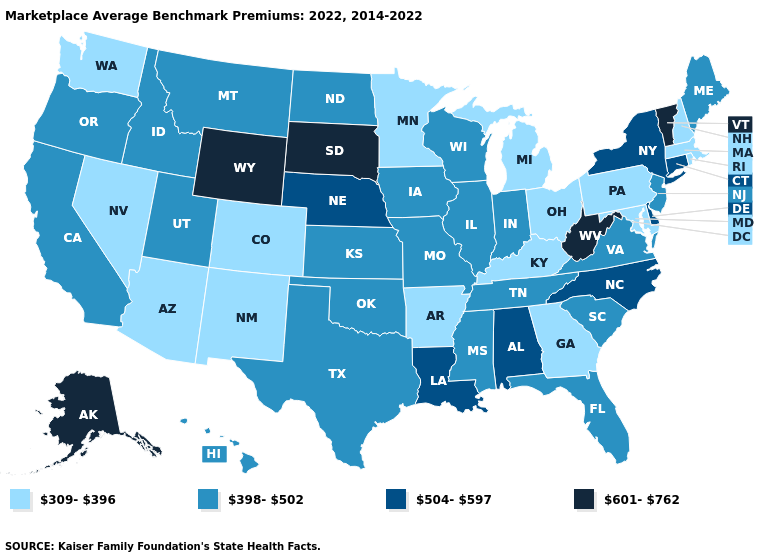How many symbols are there in the legend?
Give a very brief answer. 4. Name the states that have a value in the range 398-502?
Give a very brief answer. California, Florida, Hawaii, Idaho, Illinois, Indiana, Iowa, Kansas, Maine, Mississippi, Missouri, Montana, New Jersey, North Dakota, Oklahoma, Oregon, South Carolina, Tennessee, Texas, Utah, Virginia, Wisconsin. Does Michigan have the lowest value in the MidWest?
Keep it brief. Yes. Name the states that have a value in the range 504-597?
Answer briefly. Alabama, Connecticut, Delaware, Louisiana, Nebraska, New York, North Carolina. Name the states that have a value in the range 398-502?
Concise answer only. California, Florida, Hawaii, Idaho, Illinois, Indiana, Iowa, Kansas, Maine, Mississippi, Missouri, Montana, New Jersey, North Dakota, Oklahoma, Oregon, South Carolina, Tennessee, Texas, Utah, Virginia, Wisconsin. What is the value of Nebraska?
Keep it brief. 504-597. How many symbols are there in the legend?
Give a very brief answer. 4. Does Alaska have the highest value in the USA?
Give a very brief answer. Yes. Does Nevada have the same value as Rhode Island?
Give a very brief answer. Yes. Does Arizona have the same value as North Dakota?
Answer briefly. No. What is the highest value in the South ?
Concise answer only. 601-762. Does West Virginia have the highest value in the USA?
Quick response, please. Yes. What is the highest value in the Northeast ?
Concise answer only. 601-762. 